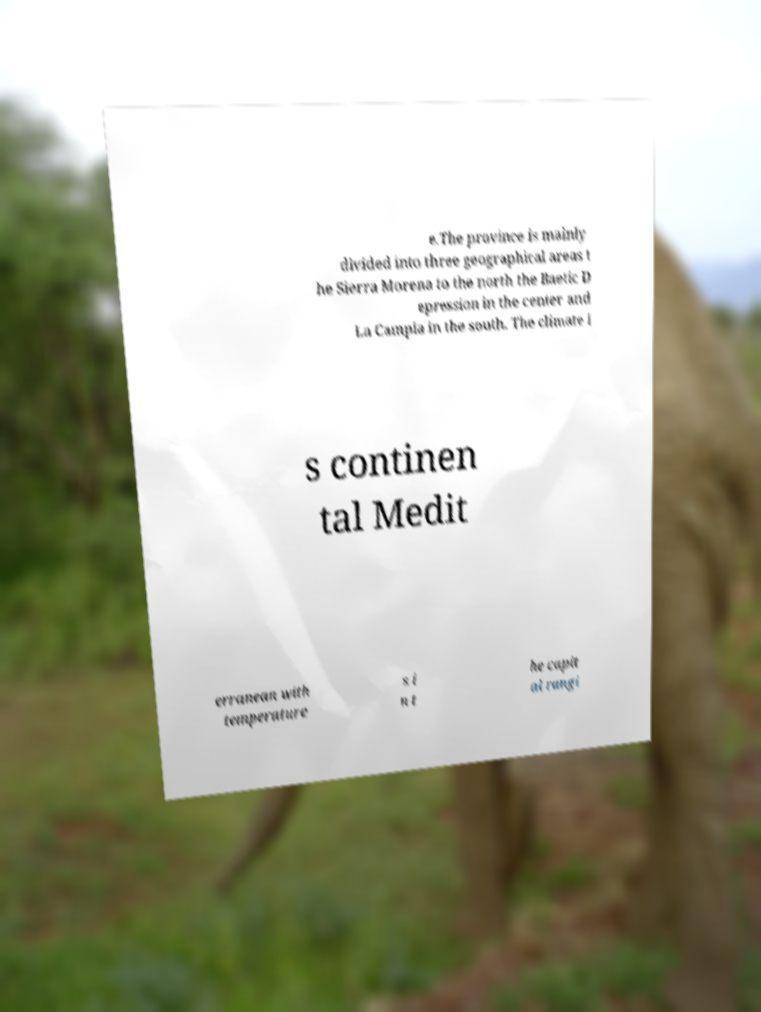There's text embedded in this image that I need extracted. Can you transcribe it verbatim? e.The province is mainly divided into three geographical areas t he Sierra Morena to the north the Baetic D epression in the center and La Campia in the south. The climate i s continen tal Medit erranean with temperature s i n t he capit al rangi 